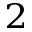<formula> <loc_0><loc_0><loc_500><loc_500>^ { 2 }</formula> 